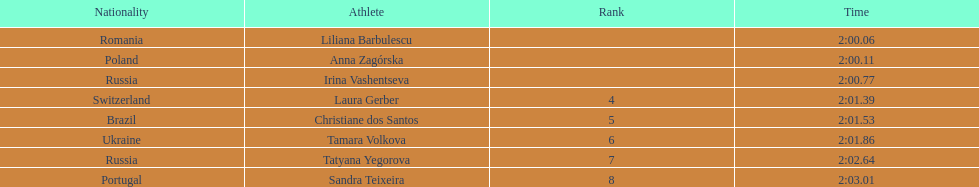Could you parse the entire table as a dict? {'header': ['Nationality', 'Athlete', 'Rank', 'Time'], 'rows': [['Romania', 'Liliana Barbulescu', '', '2:00.06'], ['Poland', 'Anna Zagórska', '', '2:00.11'], ['Russia', 'Irina Vashentseva', '', '2:00.77'], ['Switzerland', 'Laura Gerber', '4', '2:01.39'], ['Brazil', 'Christiane dos Santos', '5', '2:01.53'], ['Ukraine', 'Tamara Volkova', '6', '2:01.86'], ['Russia', 'Tatyana Yegorova', '7', '2:02.64'], ['Portugal', 'Sandra Teixeira', '8', '2:03.01']]} What is the name of the top finalist of this semifinals heat? Liliana Barbulescu. 